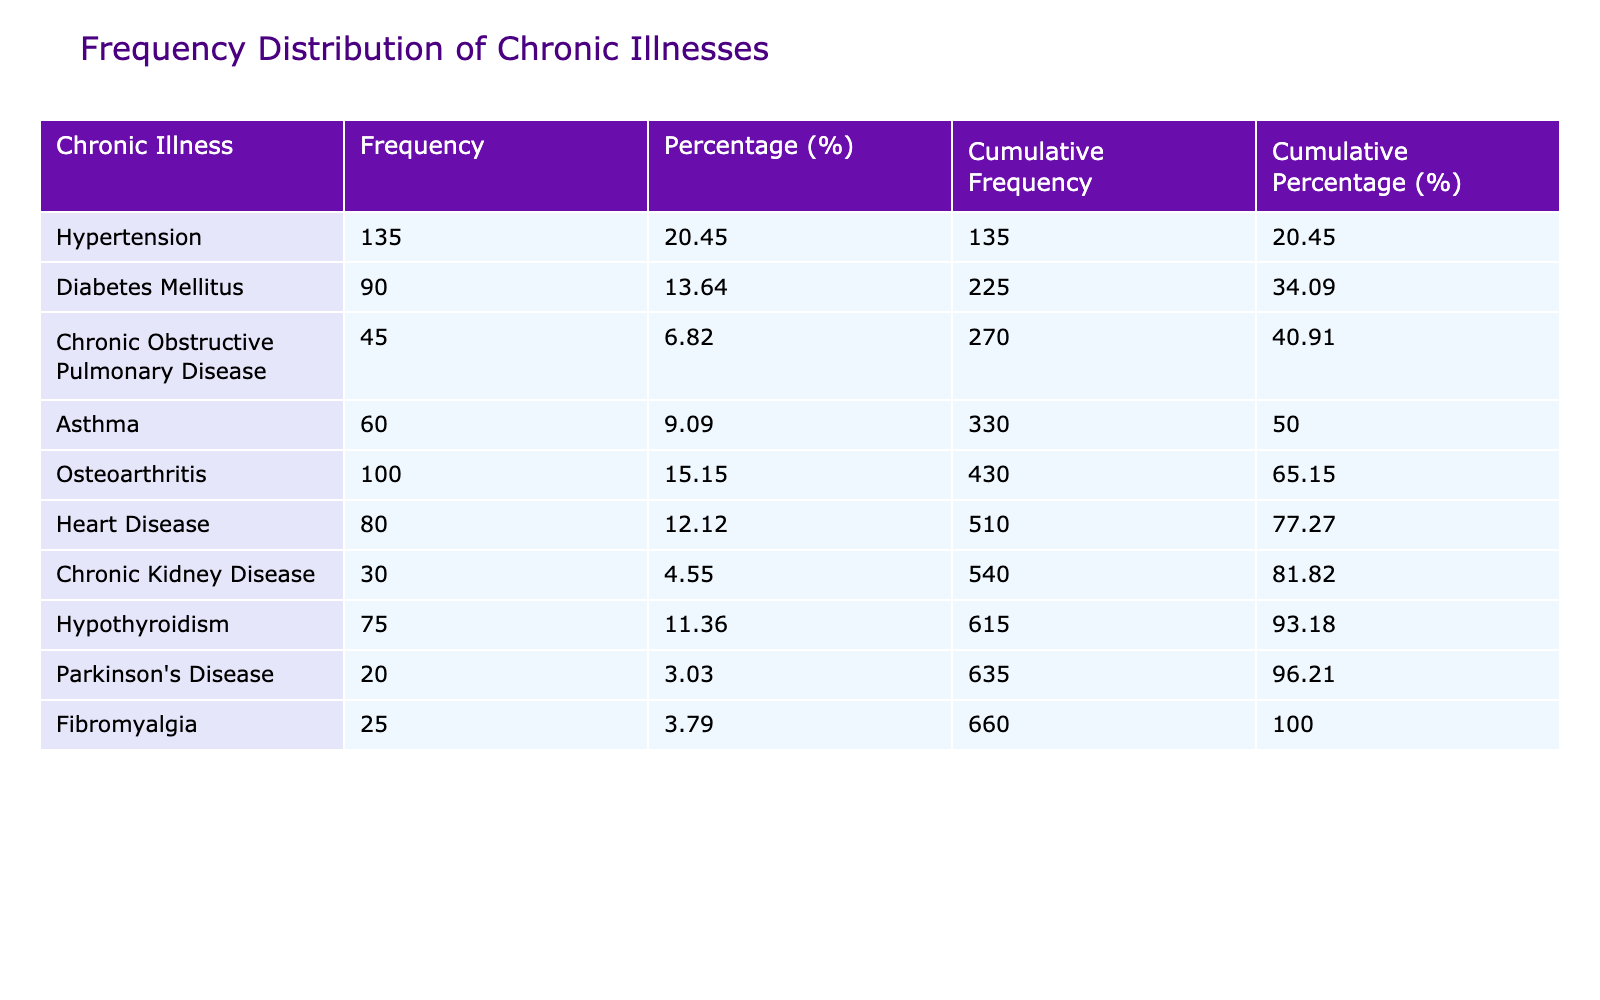What is the most commonly diagnosed chronic illness? The table indicates that the highest number of diagnosed patients is for Hypertension, with 135 patients reported.
Answer: Hypertension How many patients were diagnosed with Diabetes Mellitus? The table shows the number of diagnosed patients for Diabetes Mellitus is 90.
Answer: 90 What is the total number of diagnosed patients for Chronic Obstructive Pulmonary Disease and Asthma combined? The number of diagnosed patients for Chronic Obstructive Pulmonary Disease is 45, and for Asthma, it is 60. Adding these numbers together gives 45 + 60 = 105.
Answer: 105 Is the number of patients diagnosed with Osteoarthritis greater than the number diagnosed with Hypothyroidism? Osteoarthritis has 100 diagnosed patients, while Hypothyroidism has 75. Since 100 is greater than 75, the statement is true.
Answer: Yes What percentage of the total diagnosed patients suffer from Heart Disease? The total number of diagnosed patients is 135 + 90 + 45 + 60 + 100 + 80 + 30 + 75 + 20 + 25 =  660. Heart Disease has 80 patients, so the percentage is (80 / 660) * 100 which is approximately 12.12%.
Answer: 12.12% How many chronic illnesses have more than 70 diagnosed patients? The illnesses with more than 70 diagnosed patients are Hypertension (135), Diabetes Mellitus (90), Osteoarthritis (100), Heart Disease (80), and Hypothyroidism (75). Counting these gives a total of 5 illnesses.
Answer: 5 What is the cumulative frequency of the first three chronic illnesses listed? The cumulative frequency for the first three illnesses (Hypertension, Diabetes Mellitus, and Chronic Obstructive Pulmonary Disease) is 135 + 90 + 45 = 270.
Answer: 270 What would be the median number of diagnosed patients if we arrange the illnesses in ascending order? The illnesses in ascending order of diagnosed patients are: Parkinson's Disease (20), Fibromyalgia (25), Chronic Kidney Disease (30), Chronic Obstructive Pulmonary Disease (45), Asthma (60), Heart Disease (80), Hypothyroidism (75), Diabetes Mellitus (90), Osteoarthritis (100), and Hypertension (135). There are 10 data points, so the median will be the average of the 5th and 6th values, (60 + 80) / 2 = 70.
Answer: 70 Is the percentage of diagnosed patients with Fibromyalgia over 5%? The total diagnosed patients is 660 and Fibromyalgia has 25. Calculating the percentage gives (25 / 660) * 100 which is approximately 3.79%. Since 3.79% is less than 5%, the statement is false.
Answer: No 